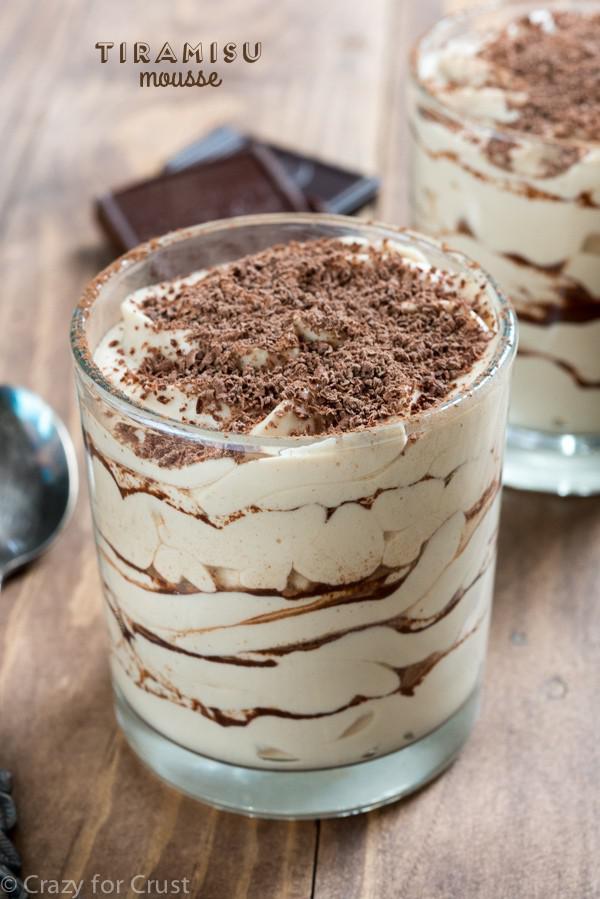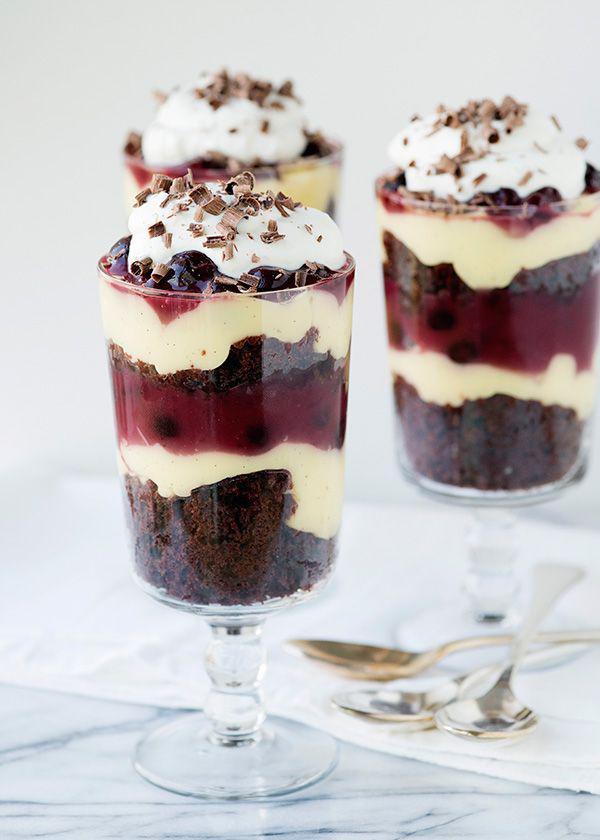The first image is the image on the left, the second image is the image on the right. Examine the images to the left and right. Is the description "In one image, a large layered dessert with chocolate garnish is made in a clear glass footed bowl, while a second image shows one or more individual desserts made with red berries." accurate? Answer yes or no. No. The first image is the image on the left, the second image is the image on the right. For the images displayed, is the sentence "One image shows a dessert with no reddish-purple layer served in one footed glass, and the other shows a non-footed glass containing a reddish-purple layer." factually correct? Answer yes or no. No. 